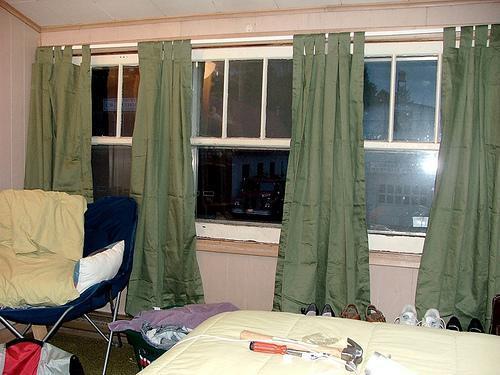How many curtains?
Give a very brief answer. 4. How many pairs of shoes are behind the bed?
Give a very brief answer. 4. How many windows are open?
Give a very brief answer. 1. 